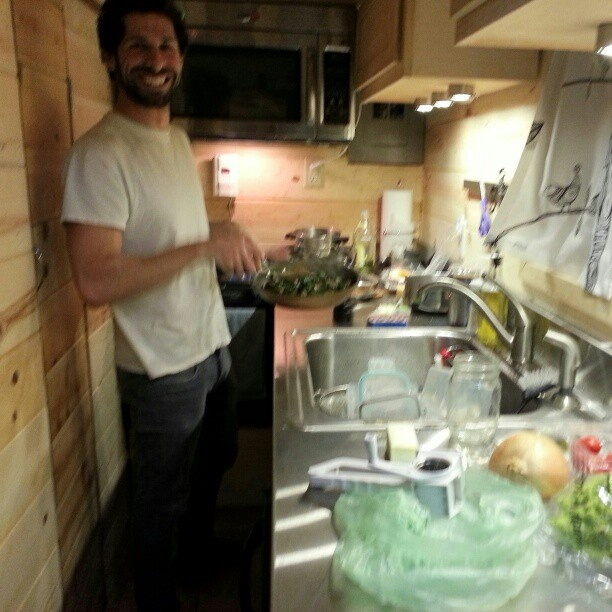Describe the objects in this image and their specific colors. I can see people in olive, black, darkgray, maroon, and gray tones, microwave in olive, black, and gray tones, sink in olive, darkgray, gray, and lightgray tones, bottle in olive, darkgray, beige, and lightgray tones, and broccoli in olive, darkgreen, and tan tones in this image. 